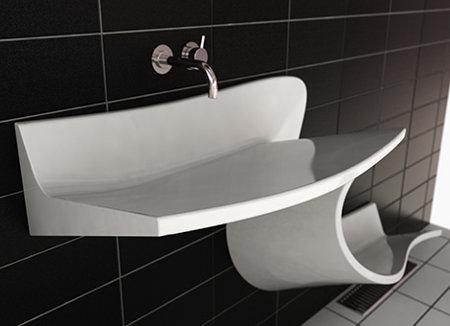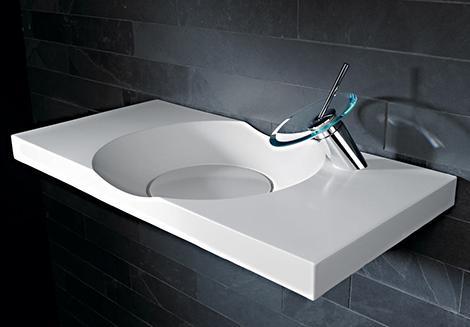The first image is the image on the left, the second image is the image on the right. For the images displayed, is the sentence "One sink is a white squiggle and one sink is hollowed out from a white rectangular block." factually correct? Answer yes or no. Yes. The first image is the image on the left, the second image is the image on the right. Assess this claim about the two images: "The sink in the image on the left curves down toward the floor.". Correct or not? Answer yes or no. Yes. 